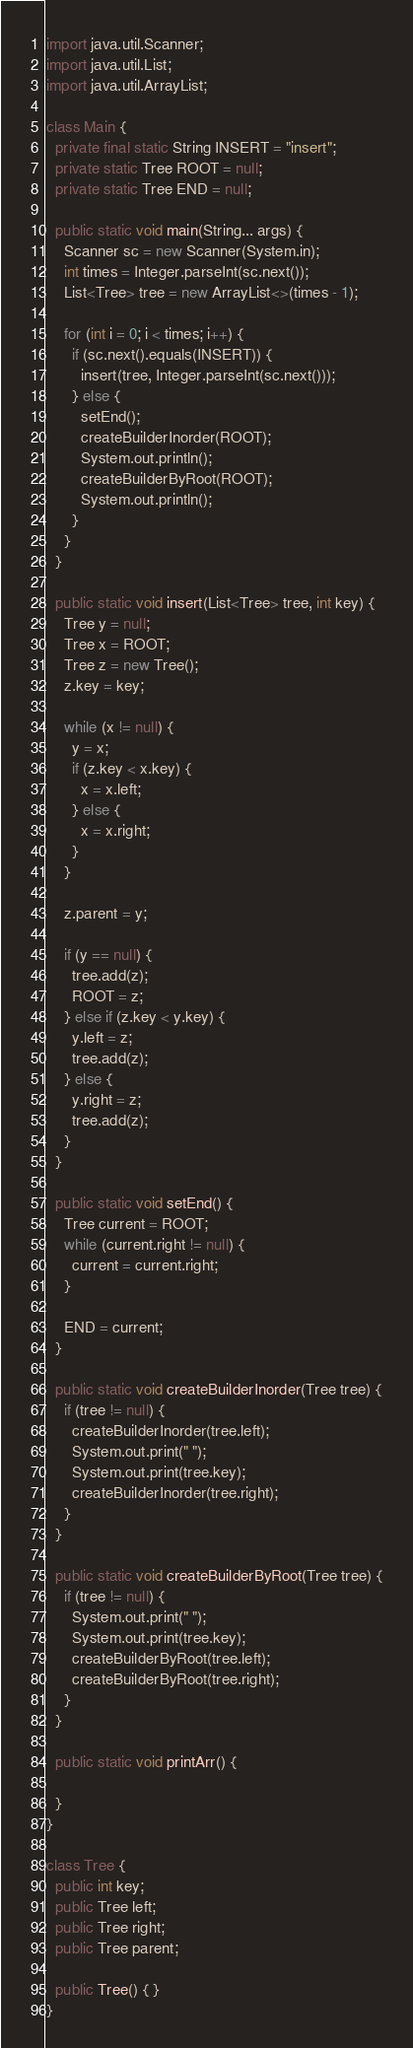Convert code to text. <code><loc_0><loc_0><loc_500><loc_500><_Java_>import java.util.Scanner;
import java.util.List;
import java.util.ArrayList;

class Main {
  private final static String INSERT = "insert";
  private static Tree ROOT = null;
  private static Tree END = null;

  public static void main(String... args) {
    Scanner sc = new Scanner(System.in);
    int times = Integer.parseInt(sc.next());
    List<Tree> tree = new ArrayList<>(times - 1);

    for (int i = 0; i < times; i++) {
      if (sc.next().equals(INSERT)) {
        insert(tree, Integer.parseInt(sc.next()));
      } else {
        setEnd();
        createBuilderInorder(ROOT);
        System.out.println();
        createBuilderByRoot(ROOT);
        System.out.println();
      }
    }
  }

  public static void insert(List<Tree> tree, int key) {
    Tree y = null;
    Tree x = ROOT;
    Tree z = new Tree();
    z.key = key;

    while (x != null) {
      y = x;
      if (z.key < x.key) {
        x = x.left;
      } else {
        x = x.right;
      }
    }

    z.parent = y;

    if (y == null) {
      tree.add(z);
      ROOT = z;
    } else if (z.key < y.key) {
      y.left = z;
      tree.add(z);
    } else {
      y.right = z;
      tree.add(z);
    }
  }

  public static void setEnd() {
    Tree current = ROOT;
    while (current.right != null) {
      current = current.right;
    }

    END = current;
  }

  public static void createBuilderInorder(Tree tree) {
    if (tree != null) {
      createBuilderInorder(tree.left);
      System.out.print(" ");
      System.out.print(tree.key);
      createBuilderInorder(tree.right);
    }
  }

  public static void createBuilderByRoot(Tree tree) {
    if (tree != null) {
      System.out.print(" ");
      System.out.print(tree.key);
      createBuilderByRoot(tree.left);
      createBuilderByRoot(tree.right);
    }
  }

  public static void printArr() {

  }
}

class Tree {
  public int key;
  public Tree left;
  public Tree right;
  public Tree parent;

  public Tree() { }
}

</code> 